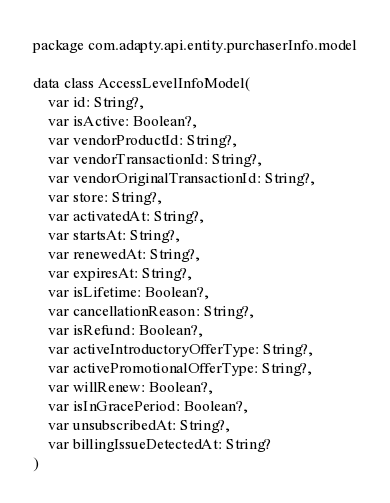Convert code to text. <code><loc_0><loc_0><loc_500><loc_500><_Kotlin_>package com.adapty.api.entity.purchaserInfo.model

data class AccessLevelInfoModel(
    var id: String?,
    var isActive: Boolean?,
    var vendorProductId: String?,
    var vendorTransactionId: String?,
    var vendorOriginalTransactionId: String?,
    var store: String?,
    var activatedAt: String?,
    var startsAt: String?,
    var renewedAt: String?,
    var expiresAt: String?,
    var isLifetime: Boolean?,
    var cancellationReason: String?,
    var isRefund: Boolean?,
    var activeIntroductoryOfferType: String?,
    var activePromotionalOfferType: String?,
    var willRenew: Boolean?,
    var isInGracePeriod: Boolean?,
    var unsubscribedAt: String?,
    var billingIssueDetectedAt: String?
)</code> 